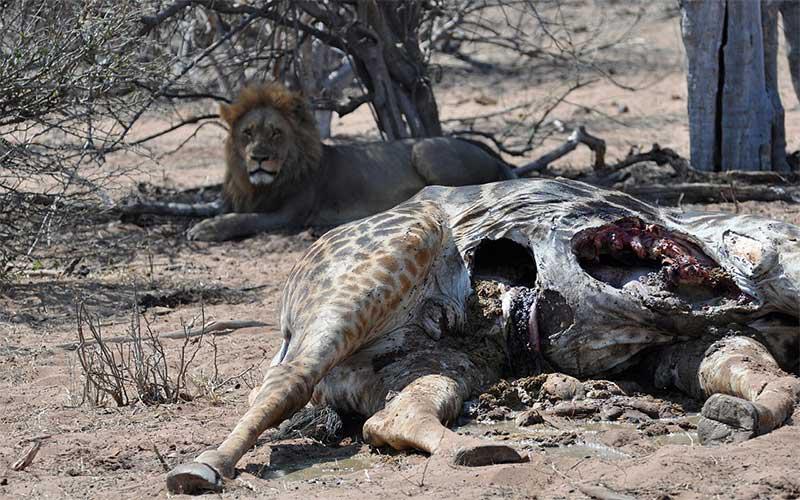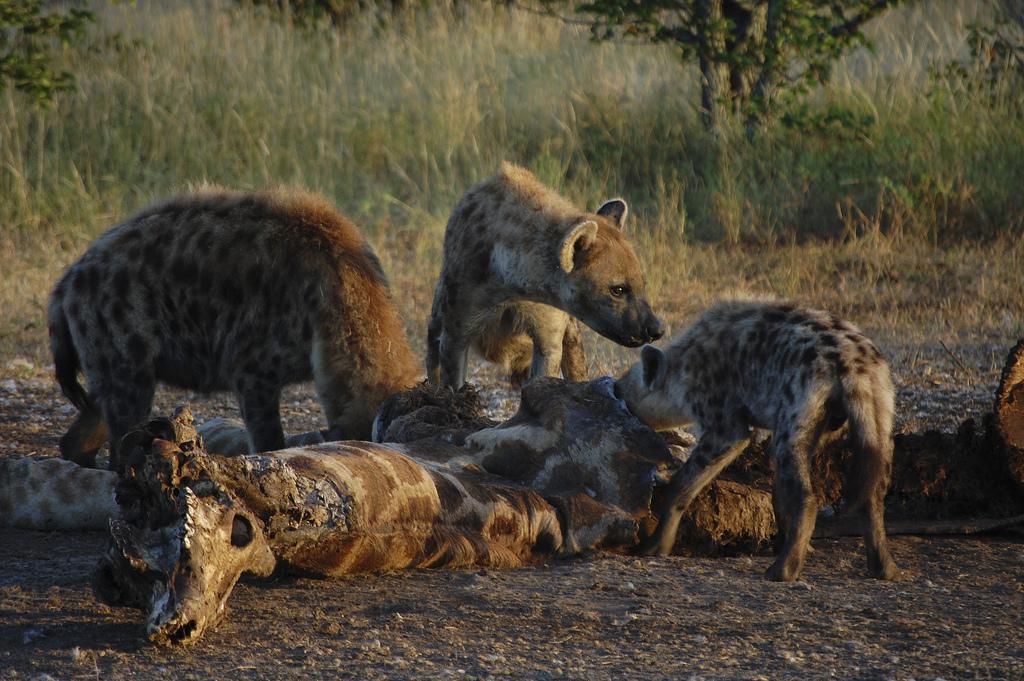The first image is the image on the left, the second image is the image on the right. For the images shown, is this caption "There are three brown and spotted hyenas  eat the carcass of a giraffe ." true? Answer yes or no. Yes. The first image is the image on the left, the second image is the image on the right. Evaluate the accuracy of this statement regarding the images: "Each image includes the carcass of a giraffe with at least some of its distinctively patterned hide intact, and the right image features a hyena with its head bent to the carcass.". Is it true? Answer yes or no. Yes. 